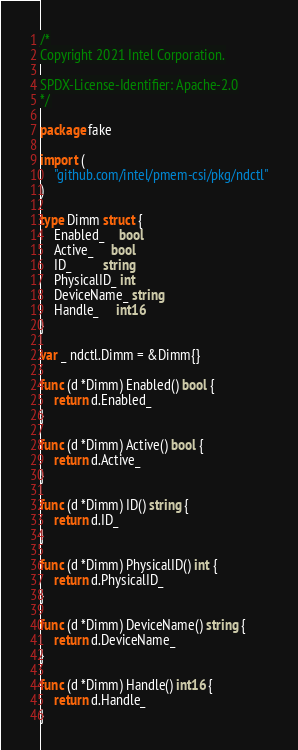Convert code to text. <code><loc_0><loc_0><loc_500><loc_500><_Go_>/*
Copyright 2021 Intel Corporation.

SPDX-License-Identifier: Apache-2.0
*/

package fake

import (
	"github.com/intel/pmem-csi/pkg/ndctl"
)

type Dimm struct {
	Enabled_    bool
	Active_     bool
	ID_         string
	PhysicalID_ int
	DeviceName_ string
	Handle_     int16
}

var _ ndctl.Dimm = &Dimm{}

func (d *Dimm) Enabled() bool {
	return d.Enabled_
}

func (d *Dimm) Active() bool {
	return d.Active_
}

func (d *Dimm) ID() string {
	return d.ID_
}

func (d *Dimm) PhysicalID() int {
	return d.PhysicalID_
}

func (d *Dimm) DeviceName() string {
	return d.DeviceName_
}

func (d *Dimm) Handle() int16 {
	return d.Handle_
}
</code> 